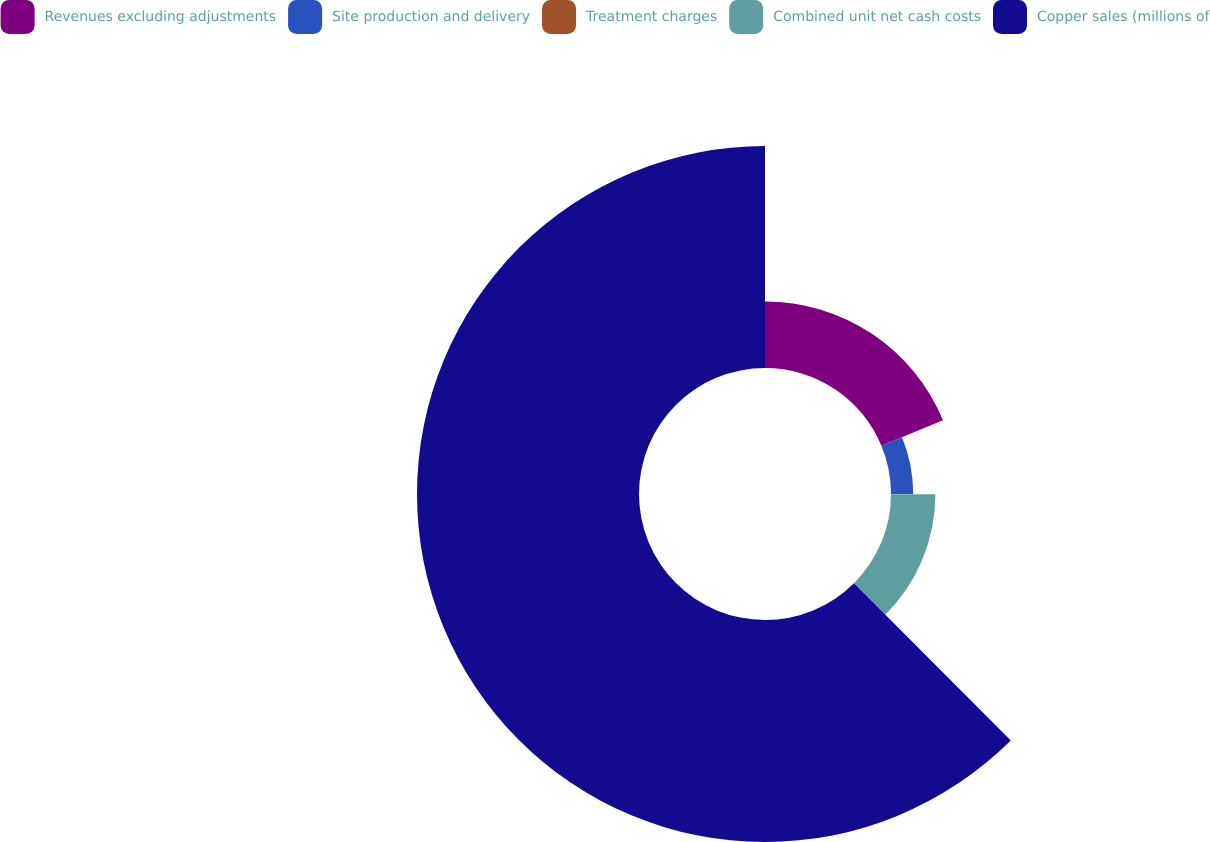Convert chart. <chart><loc_0><loc_0><loc_500><loc_500><pie_chart><fcel>Revenues excluding adjustments<fcel>Site production and delivery<fcel>Treatment charges<fcel>Combined unit net cash costs<fcel>Copper sales (millions of<nl><fcel>18.75%<fcel>6.26%<fcel>0.01%<fcel>12.5%<fcel>62.48%<nl></chart> 